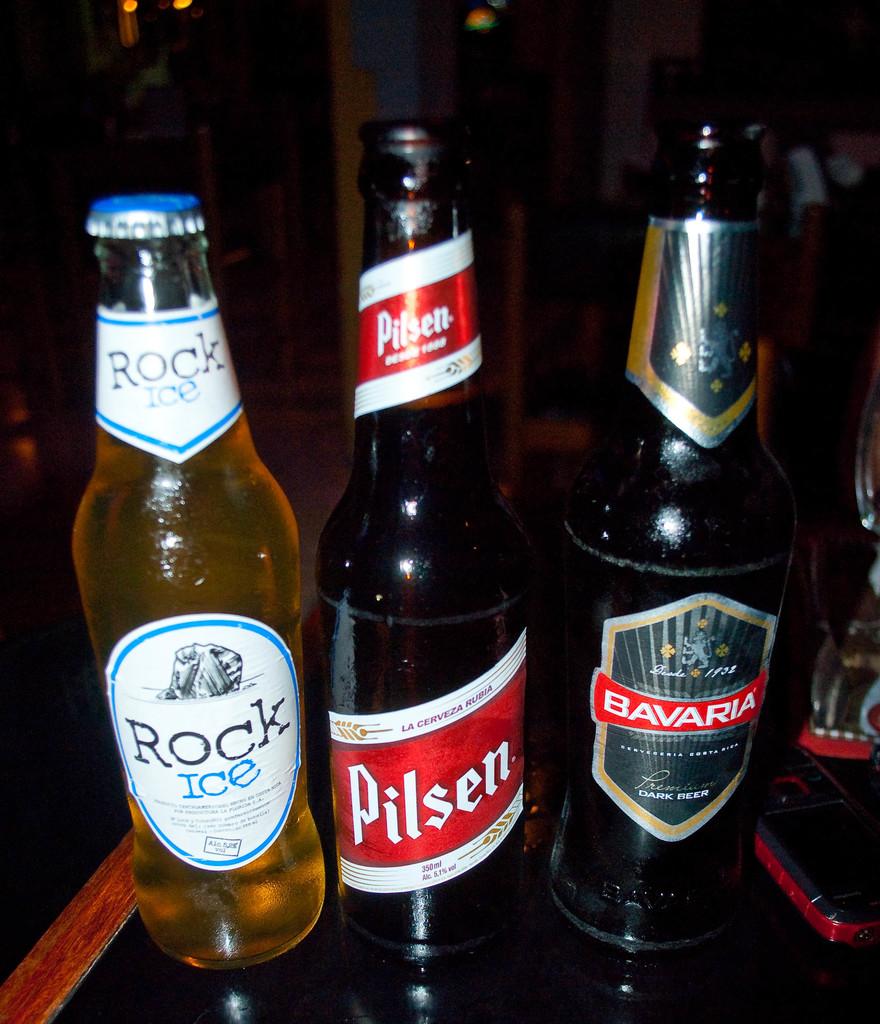What brand is the yellow beverage?
Offer a terse response. Rock ice. 